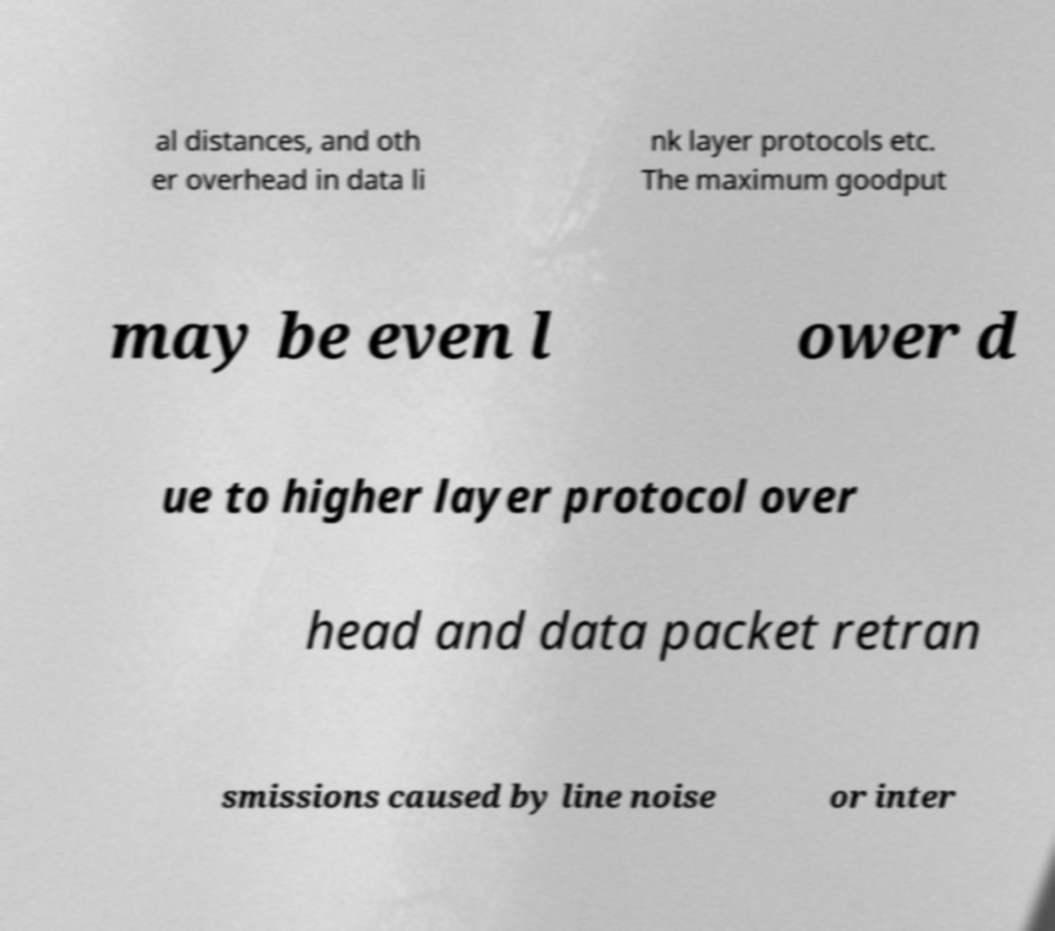Could you assist in decoding the text presented in this image and type it out clearly? al distances, and oth er overhead in data li nk layer protocols etc. The maximum goodput may be even l ower d ue to higher layer protocol over head and data packet retran smissions caused by line noise or inter 